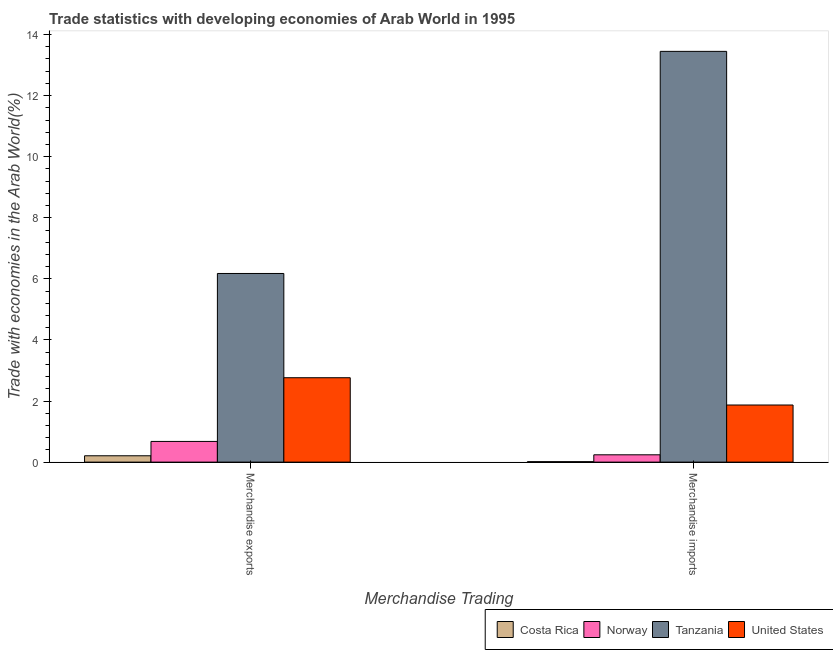How many different coloured bars are there?
Make the answer very short. 4. How many groups of bars are there?
Your answer should be very brief. 2. How many bars are there on the 2nd tick from the right?
Your answer should be very brief. 4. What is the label of the 1st group of bars from the left?
Provide a short and direct response. Merchandise exports. What is the merchandise exports in United States?
Give a very brief answer. 2.76. Across all countries, what is the maximum merchandise imports?
Offer a very short reply. 13.45. Across all countries, what is the minimum merchandise imports?
Provide a short and direct response. 0.02. In which country was the merchandise imports maximum?
Provide a short and direct response. Tanzania. What is the total merchandise imports in the graph?
Make the answer very short. 15.57. What is the difference between the merchandise imports in Tanzania and that in Norway?
Offer a very short reply. 13.21. What is the difference between the merchandise exports in Tanzania and the merchandise imports in Norway?
Make the answer very short. 5.94. What is the average merchandise exports per country?
Provide a short and direct response. 2.46. What is the difference between the merchandise exports and merchandise imports in Costa Rica?
Your answer should be compact. 0.19. In how many countries, is the merchandise imports greater than 8.4 %?
Give a very brief answer. 1. What is the ratio of the merchandise exports in Norway to that in United States?
Keep it short and to the point. 0.25. Is the merchandise exports in United States less than that in Tanzania?
Provide a short and direct response. Yes. What does the 3rd bar from the left in Merchandise imports represents?
Offer a very short reply. Tanzania. What does the 2nd bar from the right in Merchandise exports represents?
Your answer should be compact. Tanzania. How many bars are there?
Your answer should be compact. 8. How many countries are there in the graph?
Your response must be concise. 4. What is the difference between two consecutive major ticks on the Y-axis?
Offer a terse response. 2. Are the values on the major ticks of Y-axis written in scientific E-notation?
Ensure brevity in your answer.  No. Does the graph contain any zero values?
Make the answer very short. No. Does the graph contain grids?
Keep it short and to the point. No. Where does the legend appear in the graph?
Provide a short and direct response. Bottom right. What is the title of the graph?
Give a very brief answer. Trade statistics with developing economies of Arab World in 1995. Does "Bolivia" appear as one of the legend labels in the graph?
Your answer should be compact. No. What is the label or title of the X-axis?
Ensure brevity in your answer.  Merchandise Trading. What is the label or title of the Y-axis?
Make the answer very short. Trade with economies in the Arab World(%). What is the Trade with economies in the Arab World(%) of Costa Rica in Merchandise exports?
Offer a very short reply. 0.21. What is the Trade with economies in the Arab World(%) of Norway in Merchandise exports?
Offer a terse response. 0.68. What is the Trade with economies in the Arab World(%) of Tanzania in Merchandise exports?
Provide a short and direct response. 6.18. What is the Trade with economies in the Arab World(%) of United States in Merchandise exports?
Offer a very short reply. 2.76. What is the Trade with economies in the Arab World(%) of Costa Rica in Merchandise imports?
Offer a terse response. 0.02. What is the Trade with economies in the Arab World(%) in Norway in Merchandise imports?
Your response must be concise. 0.24. What is the Trade with economies in the Arab World(%) of Tanzania in Merchandise imports?
Keep it short and to the point. 13.45. What is the Trade with economies in the Arab World(%) in United States in Merchandise imports?
Give a very brief answer. 1.87. Across all Merchandise Trading, what is the maximum Trade with economies in the Arab World(%) in Costa Rica?
Your response must be concise. 0.21. Across all Merchandise Trading, what is the maximum Trade with economies in the Arab World(%) in Norway?
Provide a short and direct response. 0.68. Across all Merchandise Trading, what is the maximum Trade with economies in the Arab World(%) of Tanzania?
Your answer should be very brief. 13.45. Across all Merchandise Trading, what is the maximum Trade with economies in the Arab World(%) of United States?
Offer a very short reply. 2.76. Across all Merchandise Trading, what is the minimum Trade with economies in the Arab World(%) in Costa Rica?
Your answer should be very brief. 0.02. Across all Merchandise Trading, what is the minimum Trade with economies in the Arab World(%) in Norway?
Offer a very short reply. 0.24. Across all Merchandise Trading, what is the minimum Trade with economies in the Arab World(%) in Tanzania?
Keep it short and to the point. 6.18. Across all Merchandise Trading, what is the minimum Trade with economies in the Arab World(%) in United States?
Provide a succinct answer. 1.87. What is the total Trade with economies in the Arab World(%) of Costa Rica in the graph?
Your response must be concise. 0.22. What is the total Trade with economies in the Arab World(%) of Norway in the graph?
Give a very brief answer. 0.92. What is the total Trade with economies in the Arab World(%) in Tanzania in the graph?
Your answer should be very brief. 19.63. What is the total Trade with economies in the Arab World(%) of United States in the graph?
Provide a short and direct response. 4.63. What is the difference between the Trade with economies in the Arab World(%) in Costa Rica in Merchandise exports and that in Merchandise imports?
Your answer should be very brief. 0.19. What is the difference between the Trade with economies in the Arab World(%) in Norway in Merchandise exports and that in Merchandise imports?
Your response must be concise. 0.44. What is the difference between the Trade with economies in the Arab World(%) in Tanzania in Merchandise exports and that in Merchandise imports?
Ensure brevity in your answer.  -7.27. What is the difference between the Trade with economies in the Arab World(%) in United States in Merchandise exports and that in Merchandise imports?
Make the answer very short. 0.89. What is the difference between the Trade with economies in the Arab World(%) in Costa Rica in Merchandise exports and the Trade with economies in the Arab World(%) in Norway in Merchandise imports?
Offer a very short reply. -0.03. What is the difference between the Trade with economies in the Arab World(%) of Costa Rica in Merchandise exports and the Trade with economies in the Arab World(%) of Tanzania in Merchandise imports?
Your response must be concise. -13.24. What is the difference between the Trade with economies in the Arab World(%) in Costa Rica in Merchandise exports and the Trade with economies in the Arab World(%) in United States in Merchandise imports?
Your response must be concise. -1.66. What is the difference between the Trade with economies in the Arab World(%) of Norway in Merchandise exports and the Trade with economies in the Arab World(%) of Tanzania in Merchandise imports?
Make the answer very short. -12.77. What is the difference between the Trade with economies in the Arab World(%) in Norway in Merchandise exports and the Trade with economies in the Arab World(%) in United States in Merchandise imports?
Your answer should be compact. -1.19. What is the difference between the Trade with economies in the Arab World(%) of Tanzania in Merchandise exports and the Trade with economies in the Arab World(%) of United States in Merchandise imports?
Ensure brevity in your answer.  4.31. What is the average Trade with economies in the Arab World(%) in Costa Rica per Merchandise Trading?
Your answer should be very brief. 0.11. What is the average Trade with economies in the Arab World(%) in Norway per Merchandise Trading?
Offer a very short reply. 0.46. What is the average Trade with economies in the Arab World(%) of Tanzania per Merchandise Trading?
Your response must be concise. 9.81. What is the average Trade with economies in the Arab World(%) of United States per Merchandise Trading?
Make the answer very short. 2.32. What is the difference between the Trade with economies in the Arab World(%) of Costa Rica and Trade with economies in the Arab World(%) of Norway in Merchandise exports?
Provide a succinct answer. -0.47. What is the difference between the Trade with economies in the Arab World(%) of Costa Rica and Trade with economies in the Arab World(%) of Tanzania in Merchandise exports?
Ensure brevity in your answer.  -5.97. What is the difference between the Trade with economies in the Arab World(%) in Costa Rica and Trade with economies in the Arab World(%) in United States in Merchandise exports?
Keep it short and to the point. -2.56. What is the difference between the Trade with economies in the Arab World(%) in Norway and Trade with economies in the Arab World(%) in Tanzania in Merchandise exports?
Give a very brief answer. -5.5. What is the difference between the Trade with economies in the Arab World(%) of Norway and Trade with economies in the Arab World(%) of United States in Merchandise exports?
Ensure brevity in your answer.  -2.09. What is the difference between the Trade with economies in the Arab World(%) in Tanzania and Trade with economies in the Arab World(%) in United States in Merchandise exports?
Ensure brevity in your answer.  3.41. What is the difference between the Trade with economies in the Arab World(%) in Costa Rica and Trade with economies in the Arab World(%) in Norway in Merchandise imports?
Provide a short and direct response. -0.22. What is the difference between the Trade with economies in the Arab World(%) in Costa Rica and Trade with economies in the Arab World(%) in Tanzania in Merchandise imports?
Your response must be concise. -13.43. What is the difference between the Trade with economies in the Arab World(%) in Costa Rica and Trade with economies in the Arab World(%) in United States in Merchandise imports?
Your response must be concise. -1.85. What is the difference between the Trade with economies in the Arab World(%) of Norway and Trade with economies in the Arab World(%) of Tanzania in Merchandise imports?
Give a very brief answer. -13.21. What is the difference between the Trade with economies in the Arab World(%) in Norway and Trade with economies in the Arab World(%) in United States in Merchandise imports?
Keep it short and to the point. -1.63. What is the difference between the Trade with economies in the Arab World(%) in Tanzania and Trade with economies in the Arab World(%) in United States in Merchandise imports?
Offer a very short reply. 11.58. What is the ratio of the Trade with economies in the Arab World(%) in Costa Rica in Merchandise exports to that in Merchandise imports?
Make the answer very short. 13.56. What is the ratio of the Trade with economies in the Arab World(%) in Norway in Merchandise exports to that in Merchandise imports?
Keep it short and to the point. 2.82. What is the ratio of the Trade with economies in the Arab World(%) in Tanzania in Merchandise exports to that in Merchandise imports?
Your answer should be compact. 0.46. What is the ratio of the Trade with economies in the Arab World(%) in United States in Merchandise exports to that in Merchandise imports?
Your answer should be compact. 1.48. What is the difference between the highest and the second highest Trade with economies in the Arab World(%) of Costa Rica?
Your answer should be very brief. 0.19. What is the difference between the highest and the second highest Trade with economies in the Arab World(%) of Norway?
Provide a succinct answer. 0.44. What is the difference between the highest and the second highest Trade with economies in the Arab World(%) of Tanzania?
Provide a succinct answer. 7.27. What is the difference between the highest and the second highest Trade with economies in the Arab World(%) in United States?
Give a very brief answer. 0.89. What is the difference between the highest and the lowest Trade with economies in the Arab World(%) in Costa Rica?
Make the answer very short. 0.19. What is the difference between the highest and the lowest Trade with economies in the Arab World(%) in Norway?
Your answer should be compact. 0.44. What is the difference between the highest and the lowest Trade with economies in the Arab World(%) of Tanzania?
Your answer should be compact. 7.27. What is the difference between the highest and the lowest Trade with economies in the Arab World(%) of United States?
Your answer should be very brief. 0.89. 